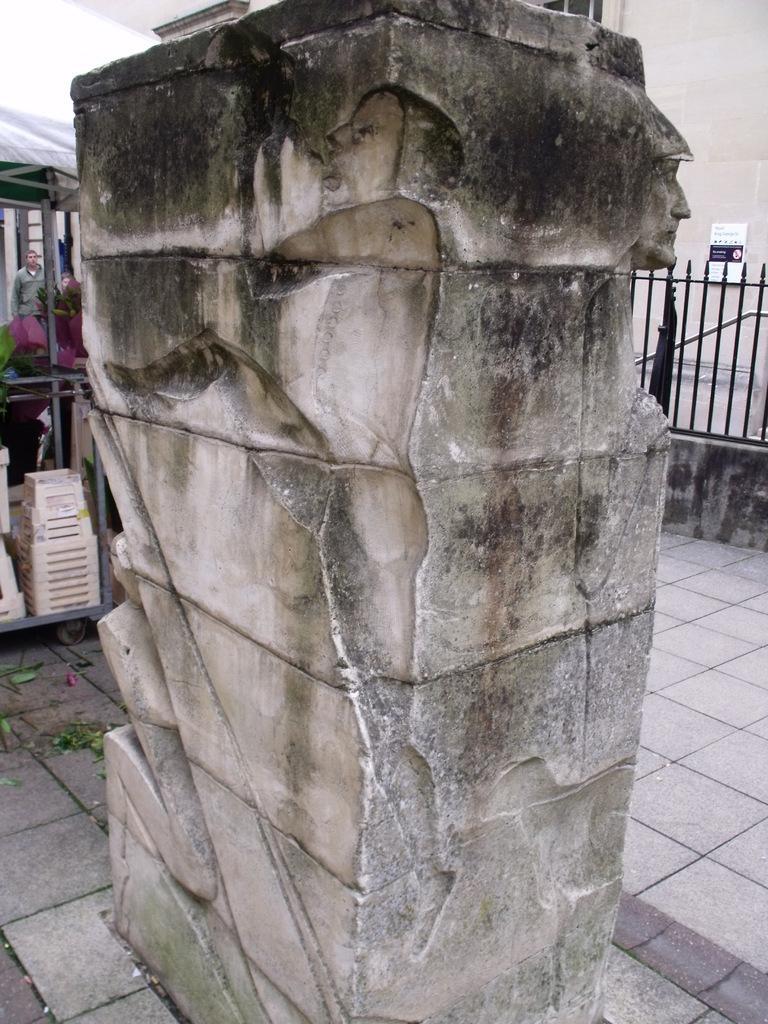Could you give a brief overview of what you see in this image? In the center of the image there is a wall with some carvings on it. In the background of the image there is fencing. There are people. At the bottom of the image there is floor. 